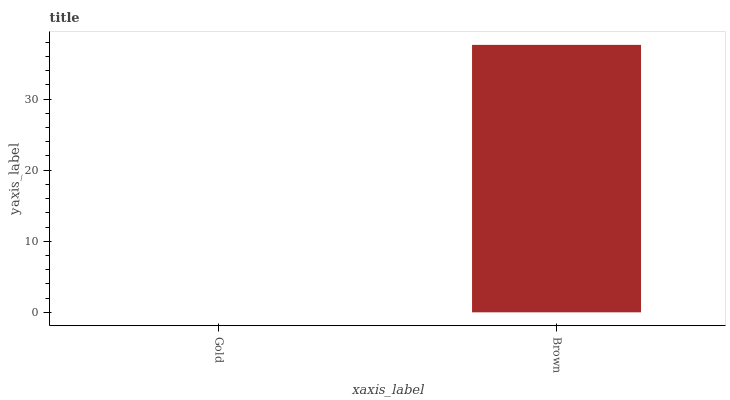Is Gold the minimum?
Answer yes or no. Yes. Is Brown the maximum?
Answer yes or no. Yes. Is Brown the minimum?
Answer yes or no. No. Is Brown greater than Gold?
Answer yes or no. Yes. Is Gold less than Brown?
Answer yes or no. Yes. Is Gold greater than Brown?
Answer yes or no. No. Is Brown less than Gold?
Answer yes or no. No. Is Brown the high median?
Answer yes or no. Yes. Is Gold the low median?
Answer yes or no. Yes. Is Gold the high median?
Answer yes or no. No. Is Brown the low median?
Answer yes or no. No. 